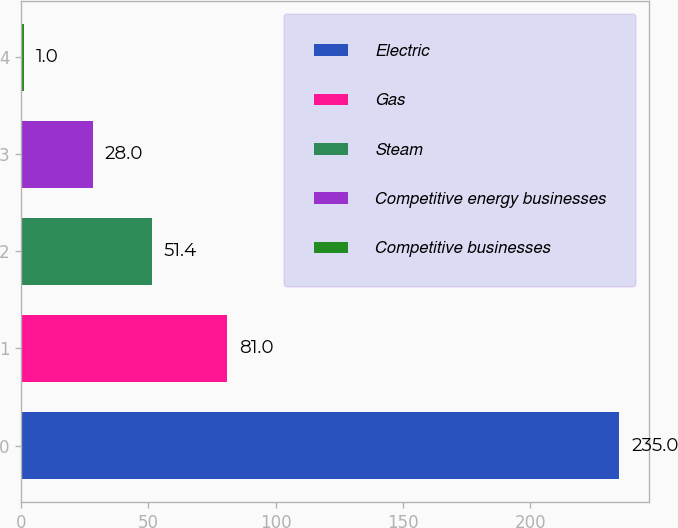<chart> <loc_0><loc_0><loc_500><loc_500><bar_chart><fcel>Electric<fcel>Gas<fcel>Steam<fcel>Competitive energy businesses<fcel>Competitive businesses<nl><fcel>235<fcel>81<fcel>51.4<fcel>28<fcel>1<nl></chart> 